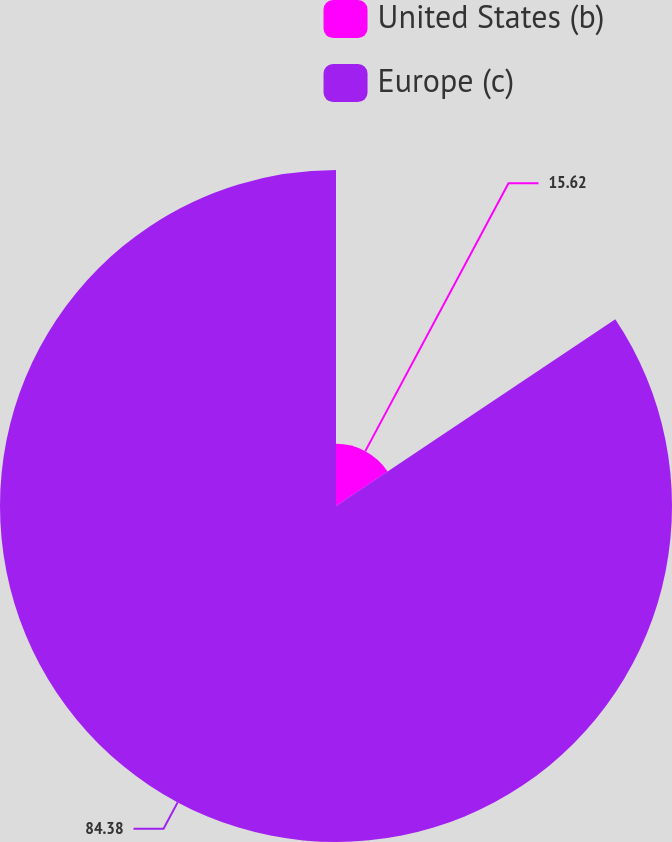Convert chart to OTSL. <chart><loc_0><loc_0><loc_500><loc_500><pie_chart><fcel>United States (b)<fcel>Europe (c)<nl><fcel>15.62%<fcel>84.38%<nl></chart> 